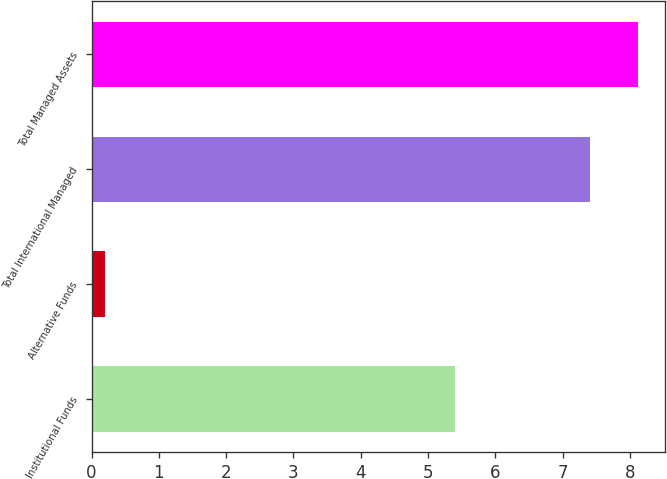Convert chart to OTSL. <chart><loc_0><loc_0><loc_500><loc_500><bar_chart><fcel>Institutional Funds<fcel>Alternative Funds<fcel>Total International Managed<fcel>Total Managed Assets<nl><fcel>5.4<fcel>0.2<fcel>7.4<fcel>8.12<nl></chart> 